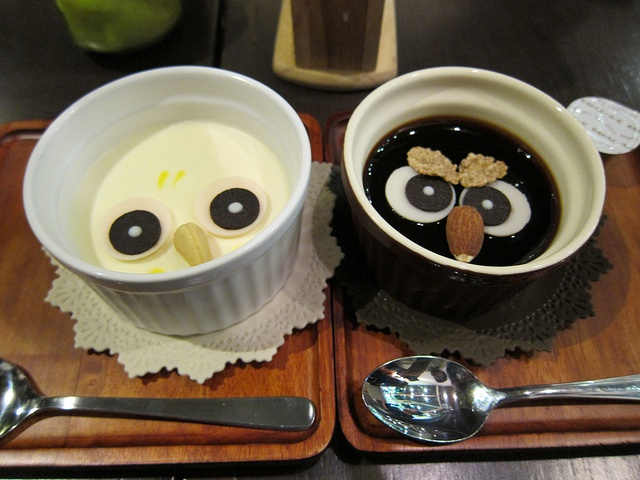Describe the objects in this image and their specific colors. I can see bowl in black, beige, darkgray, lightgray, and gray tones, bowl in black, tan, and beige tones, spoon in black, gray, darkgray, and white tones, spoon in black, gray, and white tones, and dining table in black, darkgray, and gray tones in this image. 